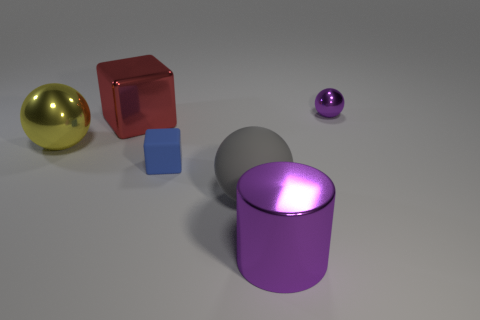There is a metallic thing that is the same color as the big cylinder; what is its size?
Your answer should be compact. Small. What is the material of the large sphere in front of the small thing in front of the small purple sphere?
Offer a very short reply. Rubber. What number of other metal things have the same color as the small metallic thing?
Offer a terse response. 1. What is the size of the yellow thing that is made of the same material as the large purple thing?
Your response must be concise. Large. There is a object that is on the right side of the metal cylinder; what is its shape?
Provide a short and direct response. Sphere. There is a gray rubber object that is the same shape as the yellow thing; what size is it?
Ensure brevity in your answer.  Large. What number of small blue cubes are right of the purple shiny object that is behind the purple metallic object that is left of the purple ball?
Make the answer very short. 0. Are there the same number of big yellow shiny objects behind the small shiny sphere and tiny blocks?
Give a very brief answer. No. What number of cylinders are small red metallic objects or yellow things?
Give a very brief answer. 0. Do the matte cube and the shiny block have the same color?
Make the answer very short. No. 